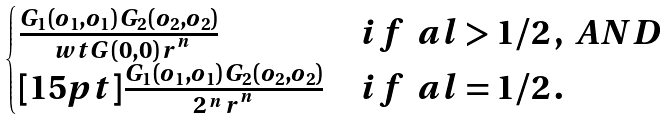<formula> <loc_0><loc_0><loc_500><loc_500>\begin{cases} \frac { G _ { 1 } ( o _ { 1 } , o _ { 1 } ) \, G _ { 2 } ( o _ { 2 } , o _ { 2 } ) } { \ w t G ( 0 , 0 ) \, r ^ { ^ { n } } } & i f \, \ a l > 1 / 2 \, , \ A N D \\ [ 1 5 p t ] \frac { G _ { 1 } ( o _ { 1 } , o _ { 1 } ) \, G _ { 2 } ( o _ { 2 } , o _ { 2 } ) } { 2 \, ^ { n } \, r ^ { ^ { n } } } & i f \, \ a l = 1 / 2 \, . \end{cases}</formula> 